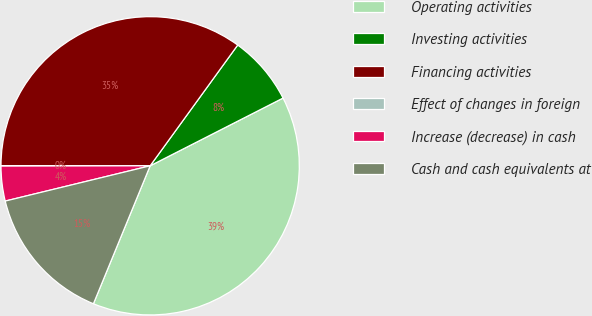<chart> <loc_0><loc_0><loc_500><loc_500><pie_chart><fcel>Operating activities<fcel>Investing activities<fcel>Financing activities<fcel>Effect of changes in foreign<fcel>Increase (decrease) in cash<fcel>Cash and cash equivalents at<nl><fcel>38.71%<fcel>7.51%<fcel>34.98%<fcel>0.03%<fcel>3.77%<fcel>14.99%<nl></chart> 